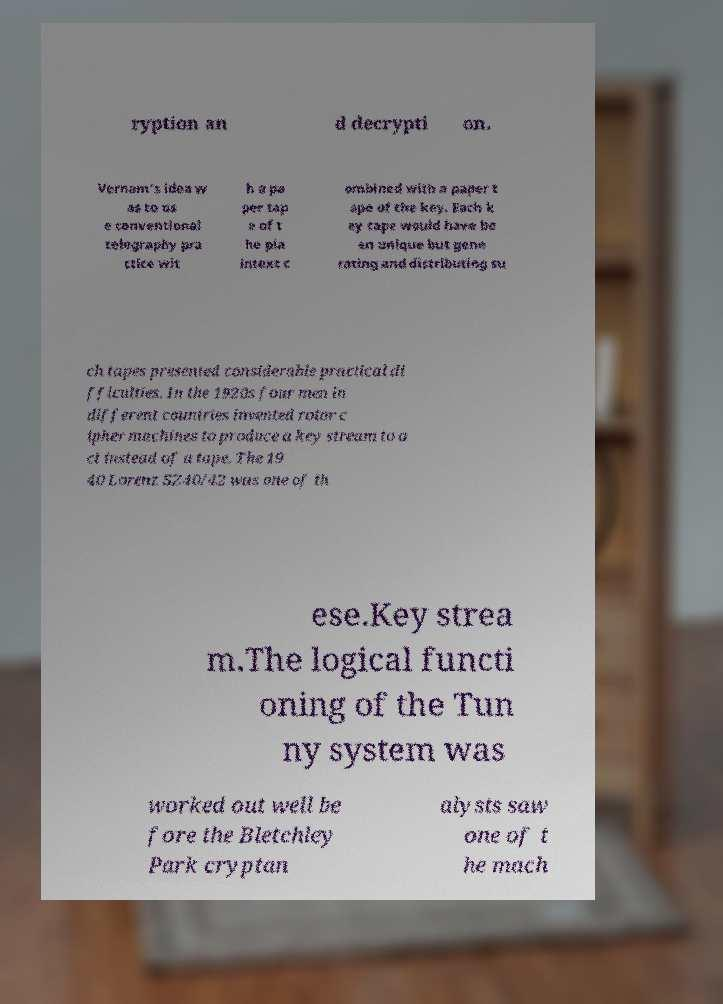Please read and relay the text visible in this image. What does it say? ryption an d decrypti on. Vernam's idea w as to us e conventional telegraphy pra ctice wit h a pa per tap e of t he pla intext c ombined with a paper t ape of the key. Each k ey tape would have be en unique but gene rating and distributing su ch tapes presented considerable practical di fficulties. In the 1920s four men in different countries invented rotor c ipher machines to produce a key stream to a ct instead of a tape. The 19 40 Lorenz SZ40/42 was one of th ese.Key strea m.The logical functi oning of the Tun ny system was worked out well be fore the Bletchley Park cryptan alysts saw one of t he mach 